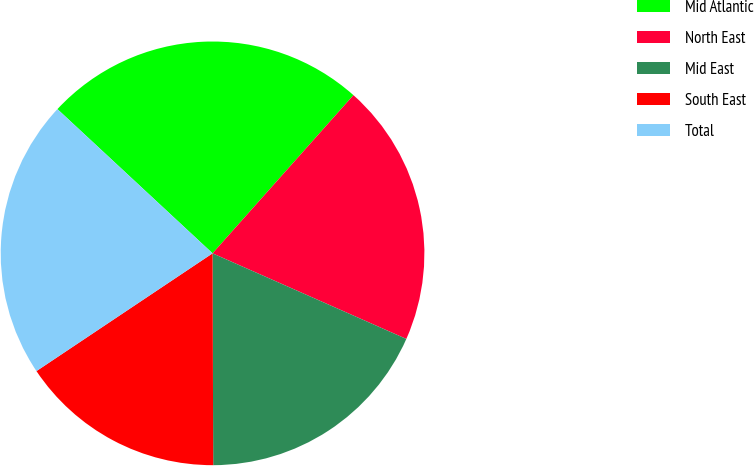Convert chart to OTSL. <chart><loc_0><loc_0><loc_500><loc_500><pie_chart><fcel>Mid Atlantic<fcel>North East<fcel>Mid East<fcel>South East<fcel>Total<nl><fcel>24.66%<fcel>20.04%<fcel>18.33%<fcel>15.67%<fcel>21.3%<nl></chart> 